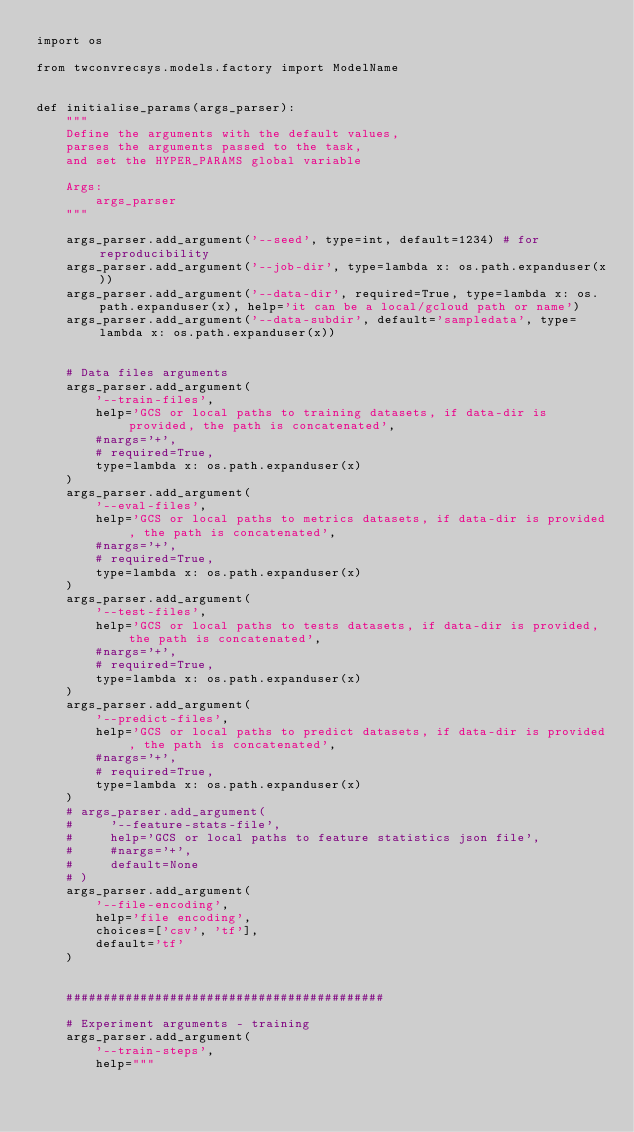Convert code to text. <code><loc_0><loc_0><loc_500><loc_500><_Python_>import os

from twconvrecsys.models.factory import ModelName


def initialise_params(args_parser):
    """
    Define the arguments with the default values,
    parses the arguments passed to the task,
    and set the HYPER_PARAMS global variable

    Args:
        args_parser
    """

    args_parser.add_argument('--seed', type=int, default=1234) # for reproducibility
    args_parser.add_argument('--job-dir', type=lambda x: os.path.expanduser(x))
    args_parser.add_argument('--data-dir', required=True, type=lambda x: os.path.expanduser(x), help='it can be a local/gcloud path or name')
    args_parser.add_argument('--data-subdir', default='sampledata', type=lambda x: os.path.expanduser(x))


    # Data files arguments
    args_parser.add_argument(
        '--train-files',
        help='GCS or local paths to training datasets, if data-dir is provided, the path is concatenated',
        #nargs='+',
        # required=True,
        type=lambda x: os.path.expanduser(x)
    )
    args_parser.add_argument(
        '--eval-files',
        help='GCS or local paths to metrics datasets, if data-dir is provided, the path is concatenated',
        #nargs='+',
        # required=True,
        type=lambda x: os.path.expanduser(x)
    )
    args_parser.add_argument(
        '--test-files',
        help='GCS or local paths to tests datasets, if data-dir is provided, the path is concatenated',
        #nargs='+',
        # required=True,
        type=lambda x: os.path.expanduser(x)
    )
    args_parser.add_argument(
        '--predict-files',
        help='GCS or local paths to predict datasets, if data-dir is provided, the path is concatenated',
        #nargs='+',
        # required=True,
        type=lambda x: os.path.expanduser(x)
    )
    # args_parser.add_argument(
    #     '--feature-stats-file',
    #     help='GCS or local paths to feature statistics json file',
    #     #nargs='+',
    #     default=None
    # )
    args_parser.add_argument(
        '--file-encoding',
        help='file encoding',
        choices=['csv', 'tf'],
        default='tf'
    )


    ###########################################

    # Experiment arguments - training
    args_parser.add_argument(
        '--train-steps',
        help="""</code> 